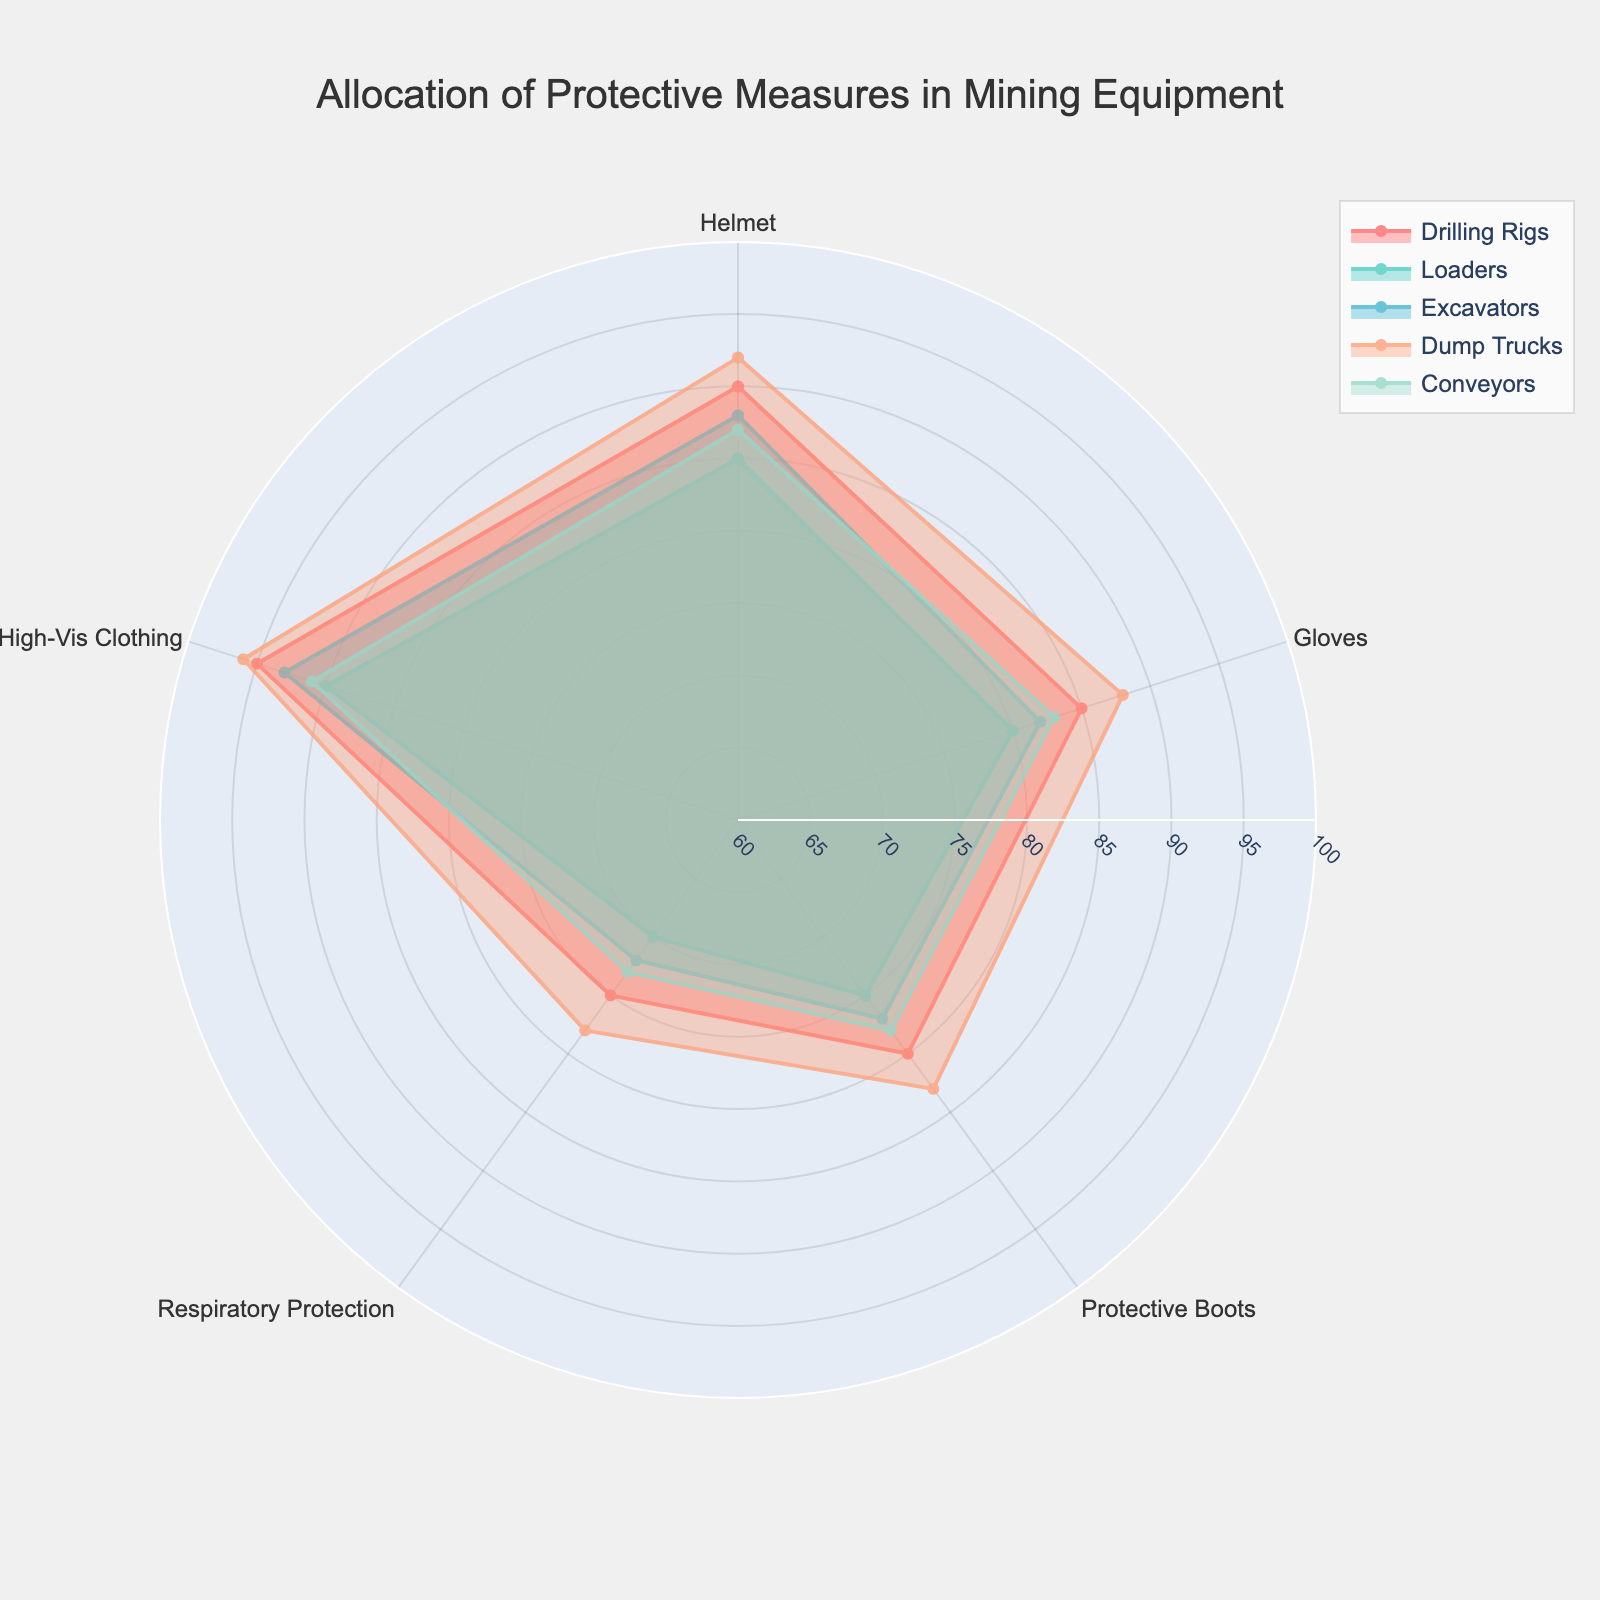What is the title of the radar chart? The title is usually at the top of the figure, often in bold or larger font. Here, it is centered at the top of the radar chart.
Answer: Allocation of Protective Measures in Mining Equipment Which protective measure has the highest allocation for Drilling Rigs? Looking at the radar chart, each piece of equipment has connected points representing different protective measures. The point with the highest value for Drilling Rigs will be the one that is farthest from the center.
Answer: High-Vis Clothing Are Respiratory Protections better allocated in Dump Trucks compared to Loaders? To answer this, compare the values of Respiratory Protection for both Dump Trucks and Loaders on the radar chart. The point for Respiratory Protection for Dump Trucks should be farther from the center than that of Loaders if it has a higher allocation.
Answer: Yes What is the difference in the allocation of Protective Boots between Excavators and Conveyors? Locate the points for Protective Boots for both Excavators and Conveyors. The difference is the absolute value of the distance between these points along the Protective Boots axis, measured from the center.
Answer: 1 Which mining equipment has the lowest allocation for Gloves? Identify the points for Gloves for each mining equipment and find the one closest to the center.
Answer: Loaders On average, how well are High-Vis Clothing allocated across all mining equipment? Calculate the average of High-Vis Clothing values for all listed mining equipment. Sum these values and divide by the number of equipment. For High-Vis Clothing: (95 + 90 + 93 + 96 + 91) / 5.
Answer: 93 In which type of protective measure do most mining equipment have similar allocations? Compare the spreads of values for each type of protective measure. The measure with the least variation (smallest range) among equipment will have the most similar allocations.
Answer: Gloves Which mining equipment shows the highest overall allocation across all protective measures? Combine all values for each piece of mining equipment and compare them. The equipment with the highest total will have the highest overall allocation. For Dump Trucks: 92 + 88 + 83 + 78 + 96.
Answer: Dump Trucks How do the allocations of Helmets compare between Drilling Rigs and Conveyors? Locate the points for Helmets for both Drilling Rigs and Conveyors. Compare these values to see which is higher.
Answer: Drilling Rigs What is the general trend between the allocation of Helmets and Respiratory Protection across all mining equipment? Observe and compare the points for Helmets and Respiratory Protection for each mining equipment. Identify any consistent increase or decrease between these two measures.
Answer: Decreases 